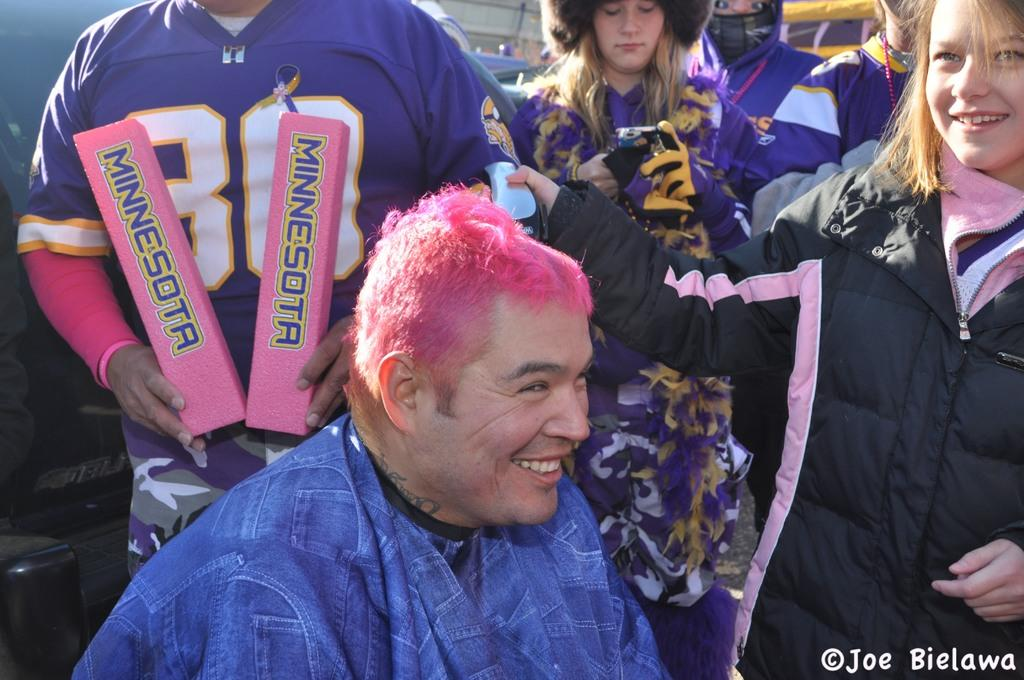<image>
Summarize the visual content of the image. Man wearing a purple jersey with the number 80 in front of another man. 